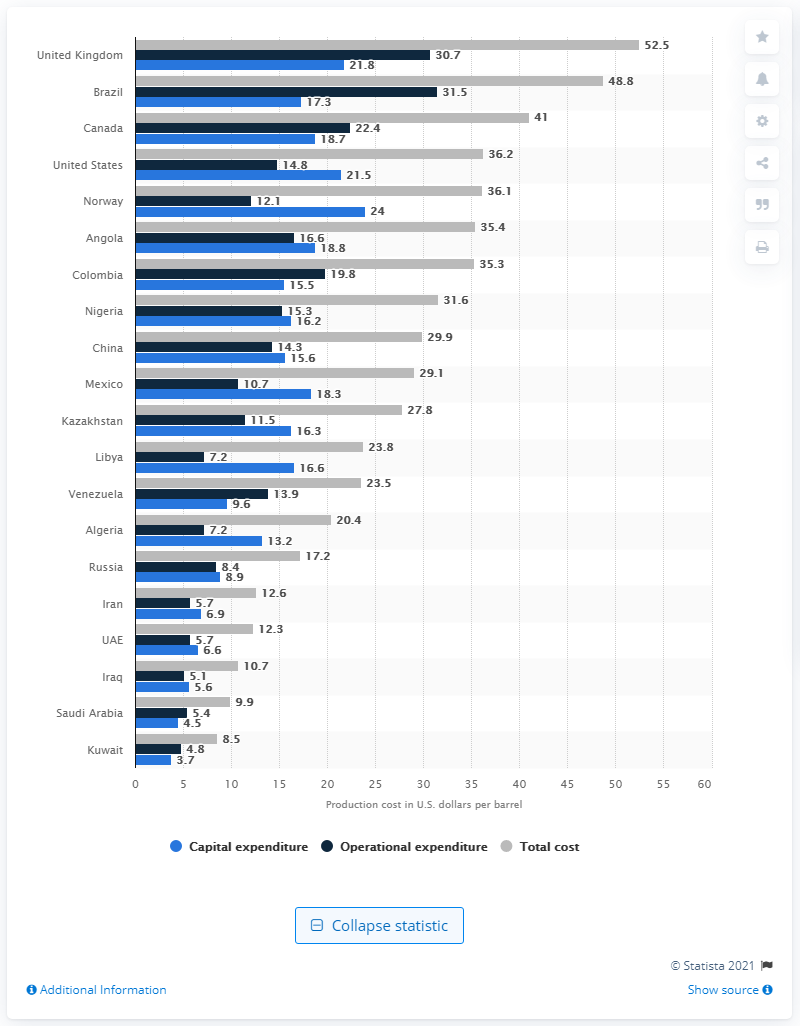Indicate a few pertinent items in this graphic. Approximately 3.7% of Kuwait's production costs were capital expenditure costs in 2019. In 2015, Kuwait had the lowest production costs per barrel of oil among all countries. 